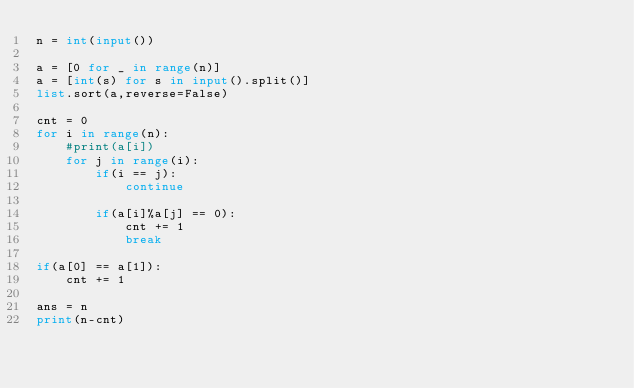<code> <loc_0><loc_0><loc_500><loc_500><_Python_>n = int(input())

a = [0 for _ in range(n)]
a = [int(s) for s in input().split()]
list.sort(a,reverse=False)

cnt = 0
for i in range(n):
    #print(a[i])
    for j in range(i):
        if(i == j):
            continue

        if(a[i]%a[j] == 0):
            cnt += 1
            break

if(a[0] == a[1]):
    cnt += 1
    
ans = n
print(n-cnt)</code> 